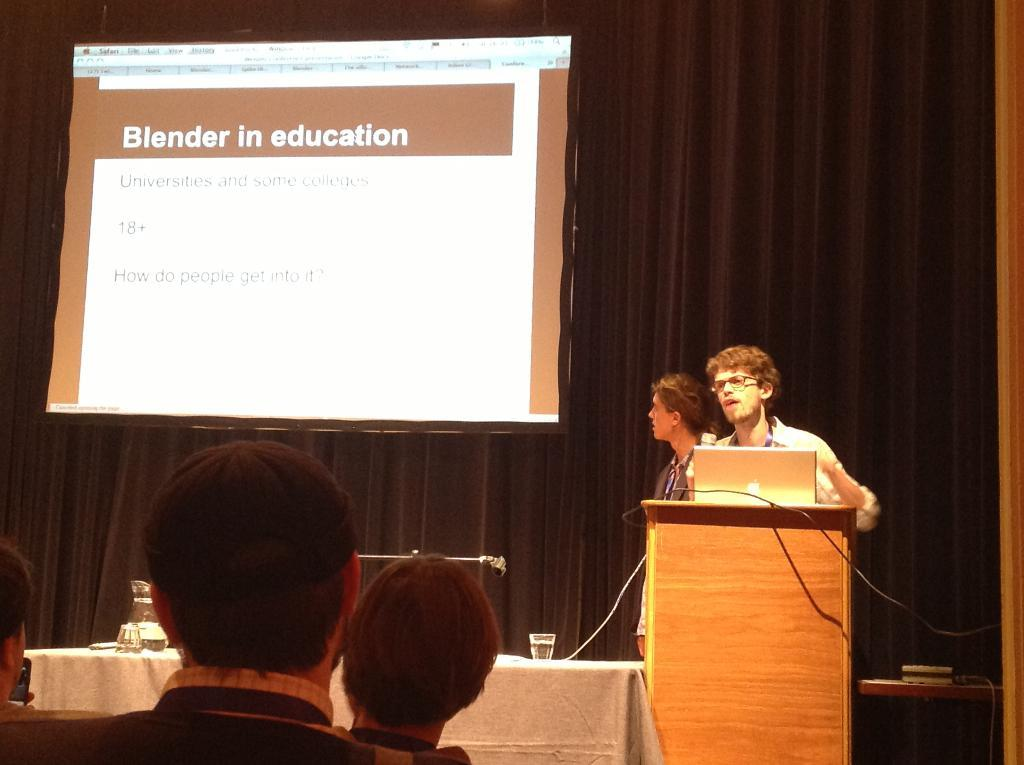What type of window treatment is visible in the image? There are curtains in the image. What can be seen on the wall in the image? There is a screen in the image. Who or what is present in the image? There are people in the image. What piece of furniture is in the image? There is a table in the image. What electronic device is on the table? There is a laptop on the table. What other object is on the table? There is a microphone (mic) in the image. What items are on the table that might be used for drinking? There are glasses on the table. How does the person in the image express their anger? There is no indication of anger in the image; the people in the image are not displaying any emotions. What part of the body is the person using to support the tray in the image? There is no tray present in the image. 